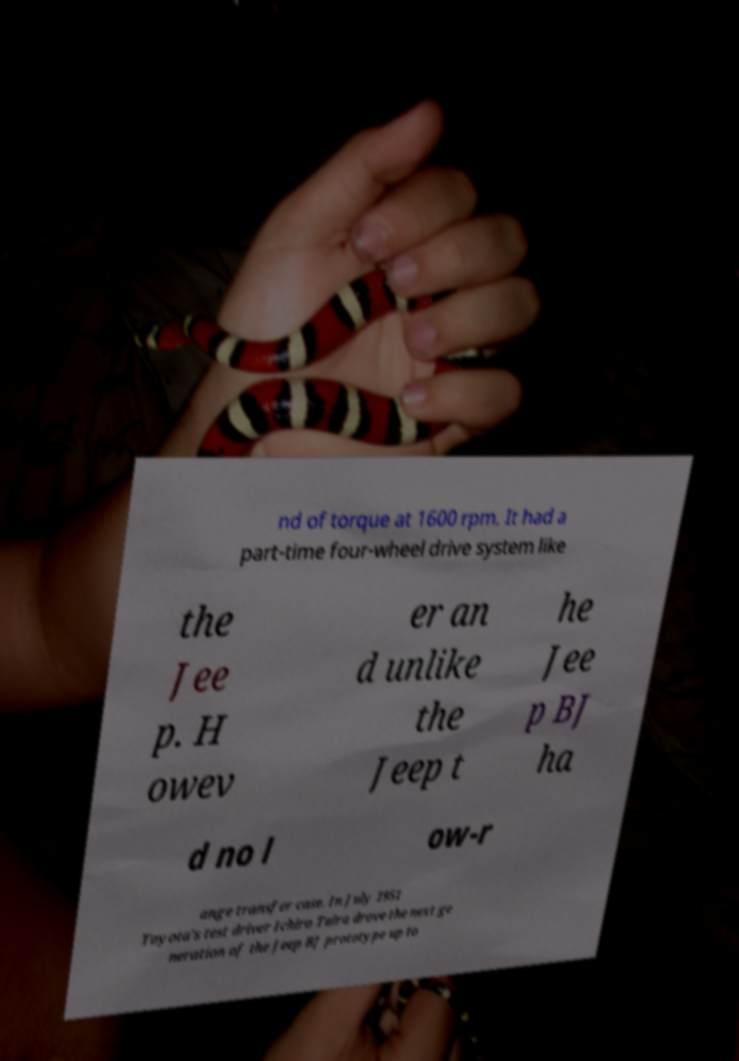Please read and relay the text visible in this image. What does it say? nd of torque at 1600 rpm. It had a part-time four-wheel drive system like the Jee p. H owev er an d unlike the Jeep t he Jee p BJ ha d no l ow-r ange transfer case. In July 1951 Toyota's test driver Ichiro Taira drove the next ge neration of the Jeep BJ prototype up to 